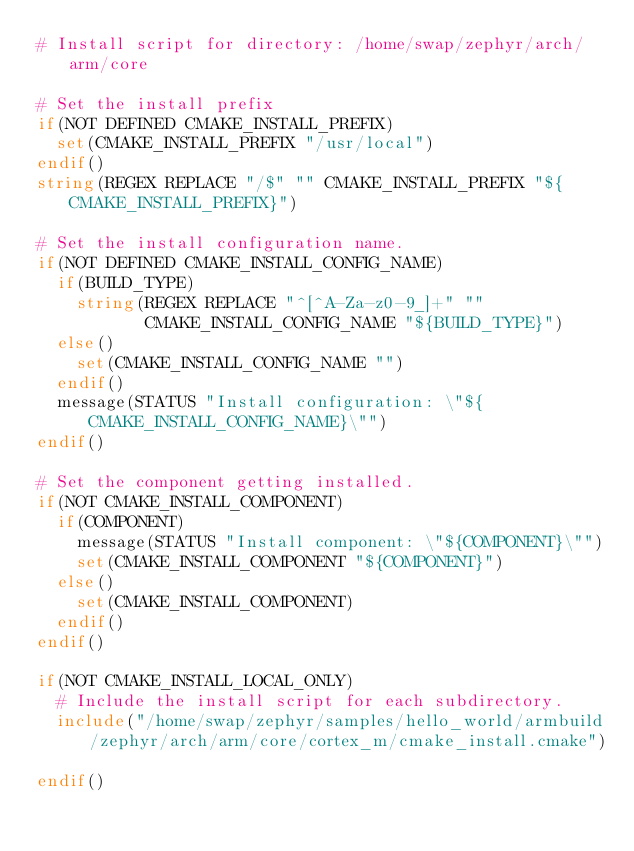<code> <loc_0><loc_0><loc_500><loc_500><_CMake_># Install script for directory: /home/swap/zephyr/arch/arm/core

# Set the install prefix
if(NOT DEFINED CMAKE_INSTALL_PREFIX)
  set(CMAKE_INSTALL_PREFIX "/usr/local")
endif()
string(REGEX REPLACE "/$" "" CMAKE_INSTALL_PREFIX "${CMAKE_INSTALL_PREFIX}")

# Set the install configuration name.
if(NOT DEFINED CMAKE_INSTALL_CONFIG_NAME)
  if(BUILD_TYPE)
    string(REGEX REPLACE "^[^A-Za-z0-9_]+" ""
           CMAKE_INSTALL_CONFIG_NAME "${BUILD_TYPE}")
  else()
    set(CMAKE_INSTALL_CONFIG_NAME "")
  endif()
  message(STATUS "Install configuration: \"${CMAKE_INSTALL_CONFIG_NAME}\"")
endif()

# Set the component getting installed.
if(NOT CMAKE_INSTALL_COMPONENT)
  if(COMPONENT)
    message(STATUS "Install component: \"${COMPONENT}\"")
    set(CMAKE_INSTALL_COMPONENT "${COMPONENT}")
  else()
    set(CMAKE_INSTALL_COMPONENT)
  endif()
endif()

if(NOT CMAKE_INSTALL_LOCAL_ONLY)
  # Include the install script for each subdirectory.
  include("/home/swap/zephyr/samples/hello_world/armbuild/zephyr/arch/arm/core/cortex_m/cmake_install.cmake")

endif()

</code> 